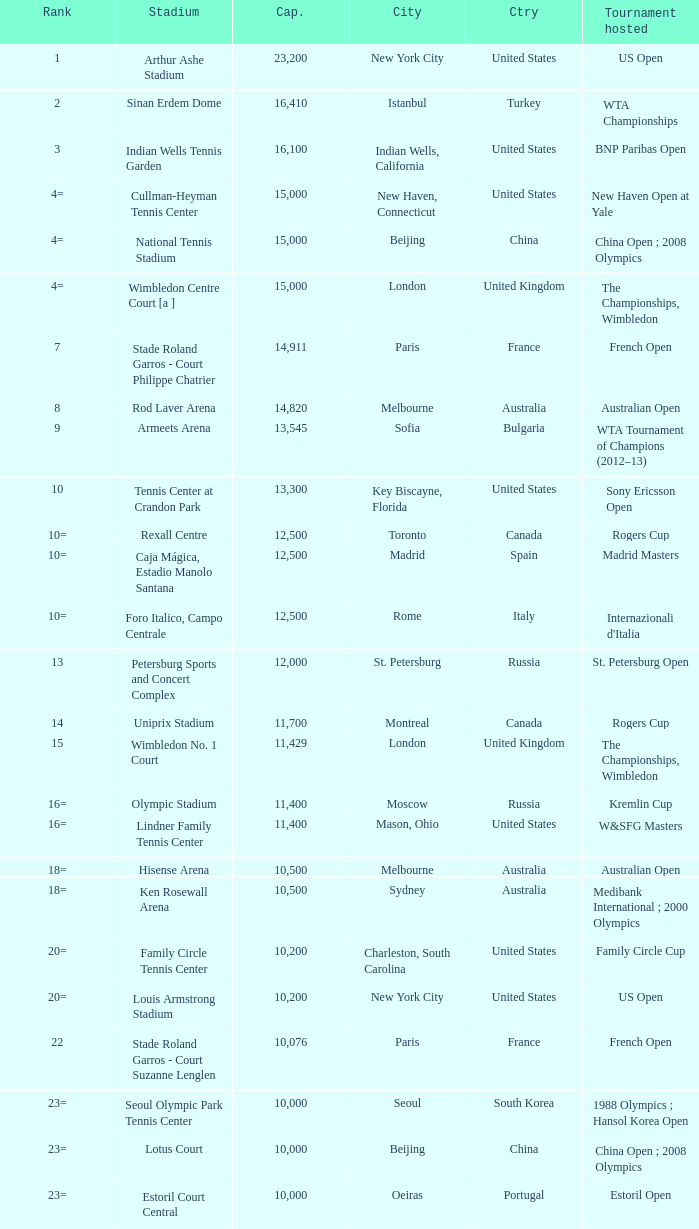What is the average capacity that has switzerland as the country? 6000.0. 